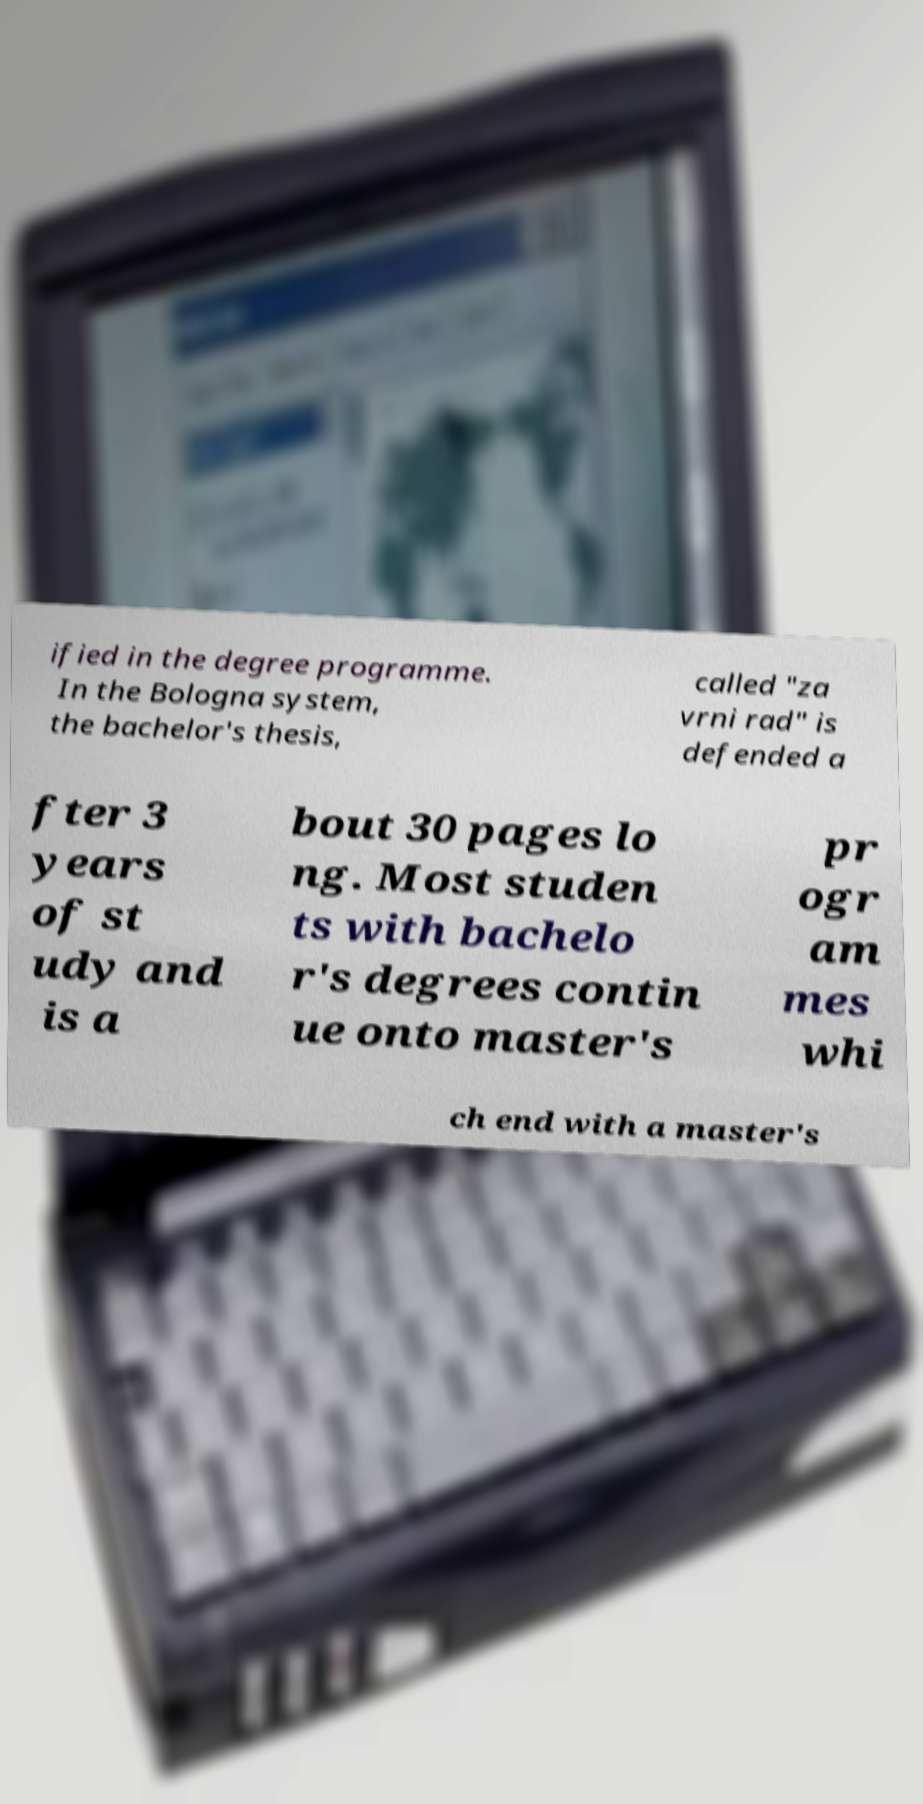I need the written content from this picture converted into text. Can you do that? ified in the degree programme. In the Bologna system, the bachelor's thesis, called "za vrni rad" is defended a fter 3 years of st udy and is a bout 30 pages lo ng. Most studen ts with bachelo r's degrees contin ue onto master's pr ogr am mes whi ch end with a master's 